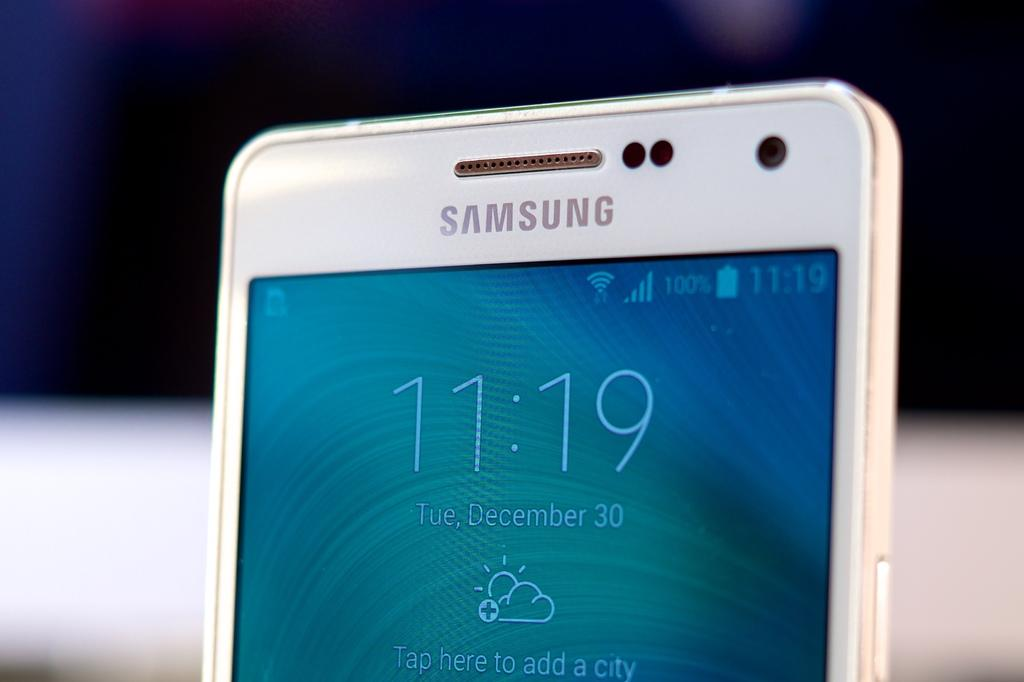<image>
Render a clear and concise summary of the photo. A samsung brand phone shows the current time is 11:19. 